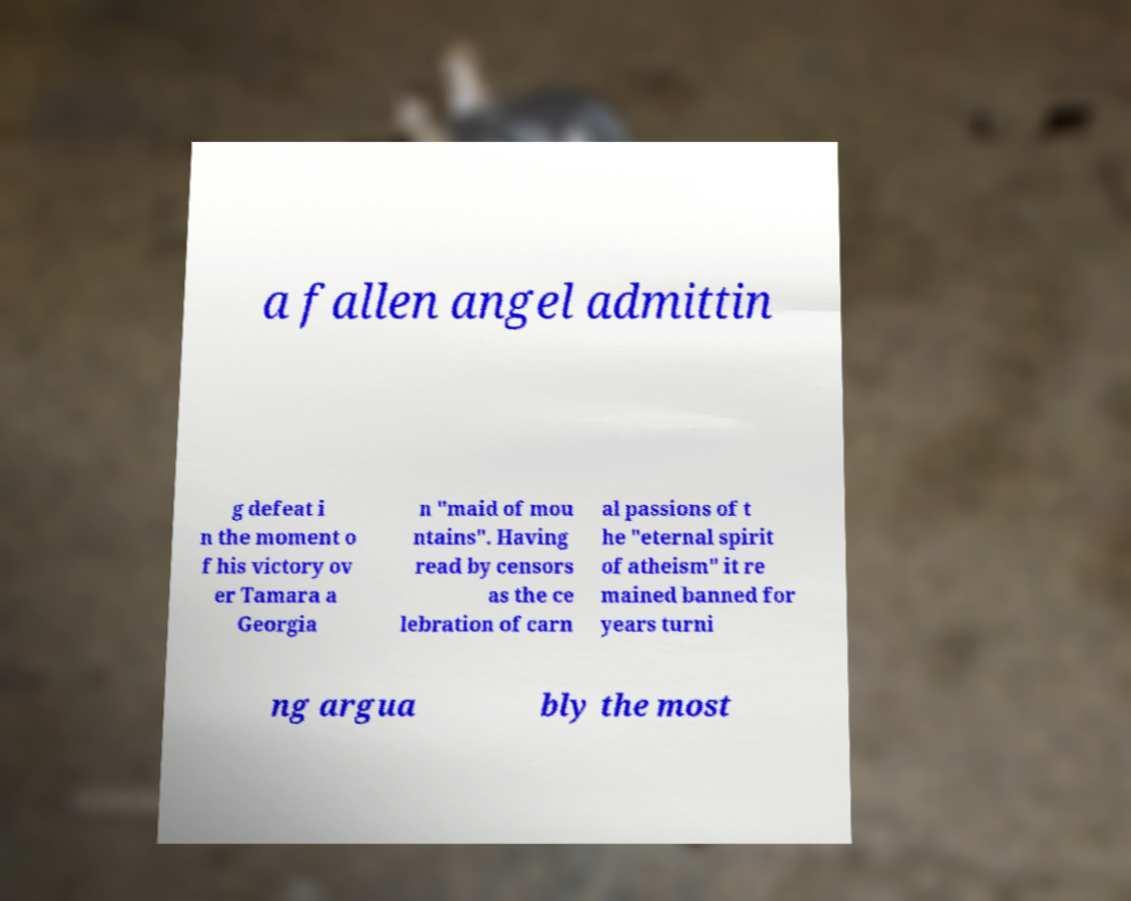I need the written content from this picture converted into text. Can you do that? a fallen angel admittin g defeat i n the moment o f his victory ov er Tamara a Georgia n "maid of mou ntains". Having read by censors as the ce lebration of carn al passions of t he "eternal spirit of atheism" it re mained banned for years turni ng argua bly the most 